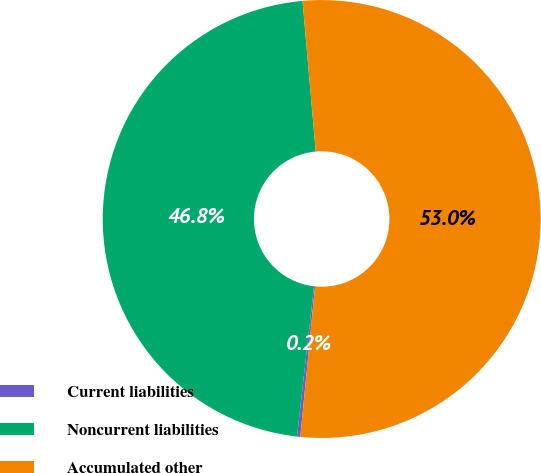Convert chart to OTSL. <chart><loc_0><loc_0><loc_500><loc_500><pie_chart><fcel>Current liabilities<fcel>Noncurrent liabilities<fcel>Accumulated other<nl><fcel>0.24%<fcel>46.81%<fcel>52.95%<nl></chart> 